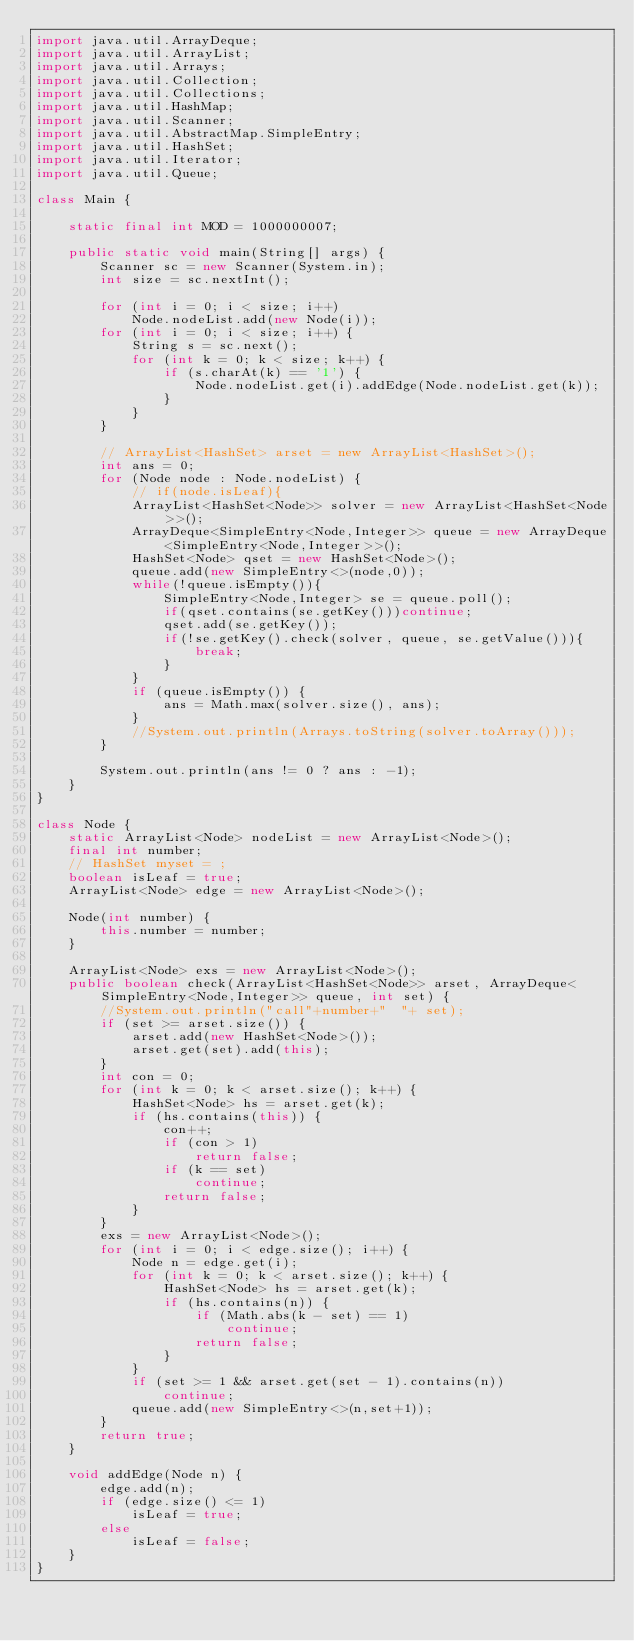Convert code to text. <code><loc_0><loc_0><loc_500><loc_500><_Java_>import java.util.ArrayDeque;
import java.util.ArrayList;
import java.util.Arrays;
import java.util.Collection;
import java.util.Collections;
import java.util.HashMap;
import java.util.Scanner;
import java.util.AbstractMap.SimpleEntry;
import java.util.HashSet;
import java.util.Iterator;
import java.util.Queue;

class Main {

    static final int MOD = 1000000007;

    public static void main(String[] args) {
        Scanner sc = new Scanner(System.in);
        int size = sc.nextInt();

        for (int i = 0; i < size; i++)
            Node.nodeList.add(new Node(i));
        for (int i = 0; i < size; i++) {
            String s = sc.next();
            for (int k = 0; k < size; k++) {
                if (s.charAt(k) == '1') {
                    Node.nodeList.get(i).addEdge(Node.nodeList.get(k));
                }
            }
        }

        // ArrayList<HashSet> arset = new ArrayList<HashSet>();
        int ans = 0;
        for (Node node : Node.nodeList) {
            // if(node.isLeaf){
            ArrayList<HashSet<Node>> solver = new ArrayList<HashSet<Node>>();
            ArrayDeque<SimpleEntry<Node,Integer>> queue = new ArrayDeque<SimpleEntry<Node,Integer>>();
            HashSet<Node> qset = new HashSet<Node>();
            queue.add(new SimpleEntry<>(node,0));
            while(!queue.isEmpty()){
                SimpleEntry<Node,Integer> se = queue.poll();
                if(qset.contains(se.getKey()))continue;
                qset.add(se.getKey());
                if(!se.getKey().check(solver, queue, se.getValue())){
                    break;
                }
            }
            if (queue.isEmpty()) {
                ans = Math.max(solver.size(), ans);
            }
            //System.out.println(Arrays.toString(solver.toArray()));
        }

        System.out.println(ans != 0 ? ans : -1);
    }
}

class Node {
    static ArrayList<Node> nodeList = new ArrayList<Node>();
    final int number;
    // HashSet myset = ;
    boolean isLeaf = true;
    ArrayList<Node> edge = new ArrayList<Node>();

    Node(int number) {
        this.number = number;
    }

    ArrayList<Node> exs = new ArrayList<Node>();
    public boolean check(ArrayList<HashSet<Node>> arset, ArrayDeque<SimpleEntry<Node,Integer>> queue, int set) {
        //System.out.println("call"+number+"  "+ set);
        if (set >= arset.size()) {
            arset.add(new HashSet<Node>());
            arset.get(set).add(this);
        }
        int con = 0;
        for (int k = 0; k < arset.size(); k++) {
            HashSet<Node> hs = arset.get(k);
            if (hs.contains(this)) {
                con++;
                if (con > 1)
                    return false;
                if (k == set)
                    continue;
                return false;
            }
        }
        exs = new ArrayList<Node>();
        for (int i = 0; i < edge.size(); i++) {
            Node n = edge.get(i);
            for (int k = 0; k < arset.size(); k++) {
                HashSet<Node> hs = arset.get(k);
                if (hs.contains(n)) {
                    if (Math.abs(k - set) == 1)
                        continue;
                    return false;
                }
            }
            if (set >= 1 && arset.get(set - 1).contains(n))
                continue;
            queue.add(new SimpleEntry<>(n,set+1));
        }
        return true;
    }

    void addEdge(Node n) {
        edge.add(n);
        if (edge.size() <= 1)
            isLeaf = true;
        else
            isLeaf = false;
    }
}</code> 